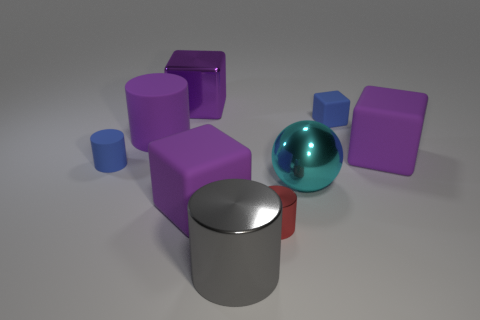Subtract all green spheres. How many purple blocks are left? 3 Subtract 1 cylinders. How many cylinders are left? 3 Subtract all balls. How many objects are left? 8 Subtract all large purple metal objects. Subtract all small blue matte blocks. How many objects are left? 7 Add 6 gray shiny cylinders. How many gray shiny cylinders are left? 7 Add 3 purple matte blocks. How many purple matte blocks exist? 5 Subtract 1 red cylinders. How many objects are left? 8 